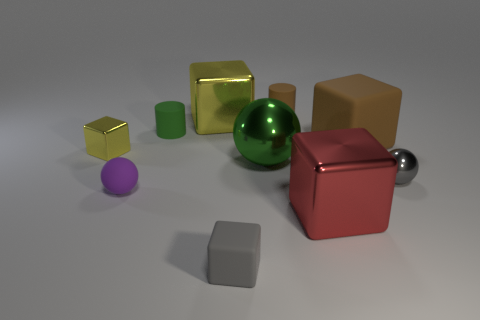Do the small rubber block and the tiny metal sphere have the same color?
Your answer should be compact. Yes. What number of yellow objects are made of the same material as the big yellow block?
Provide a succinct answer. 1. Does the yellow metallic thing that is to the right of the rubber ball have the same size as the big brown block?
Your response must be concise. Yes. There is a block that is the same size as the gray matte object; what is its color?
Ensure brevity in your answer.  Yellow. How many yellow shiny objects are left of the small gray rubber cube?
Provide a short and direct response. 2. Are any big shiny things visible?
Give a very brief answer. Yes. There is a metallic object behind the small yellow shiny thing that is behind the tiny gray thing that is behind the purple ball; how big is it?
Your response must be concise. Large. What number of other objects are there of the same size as the brown matte block?
Offer a very short reply. 3. How big is the matte cube that is behind the big green metallic ball?
Your response must be concise. Large. Is there anything else that has the same color as the small metallic sphere?
Ensure brevity in your answer.  Yes. 